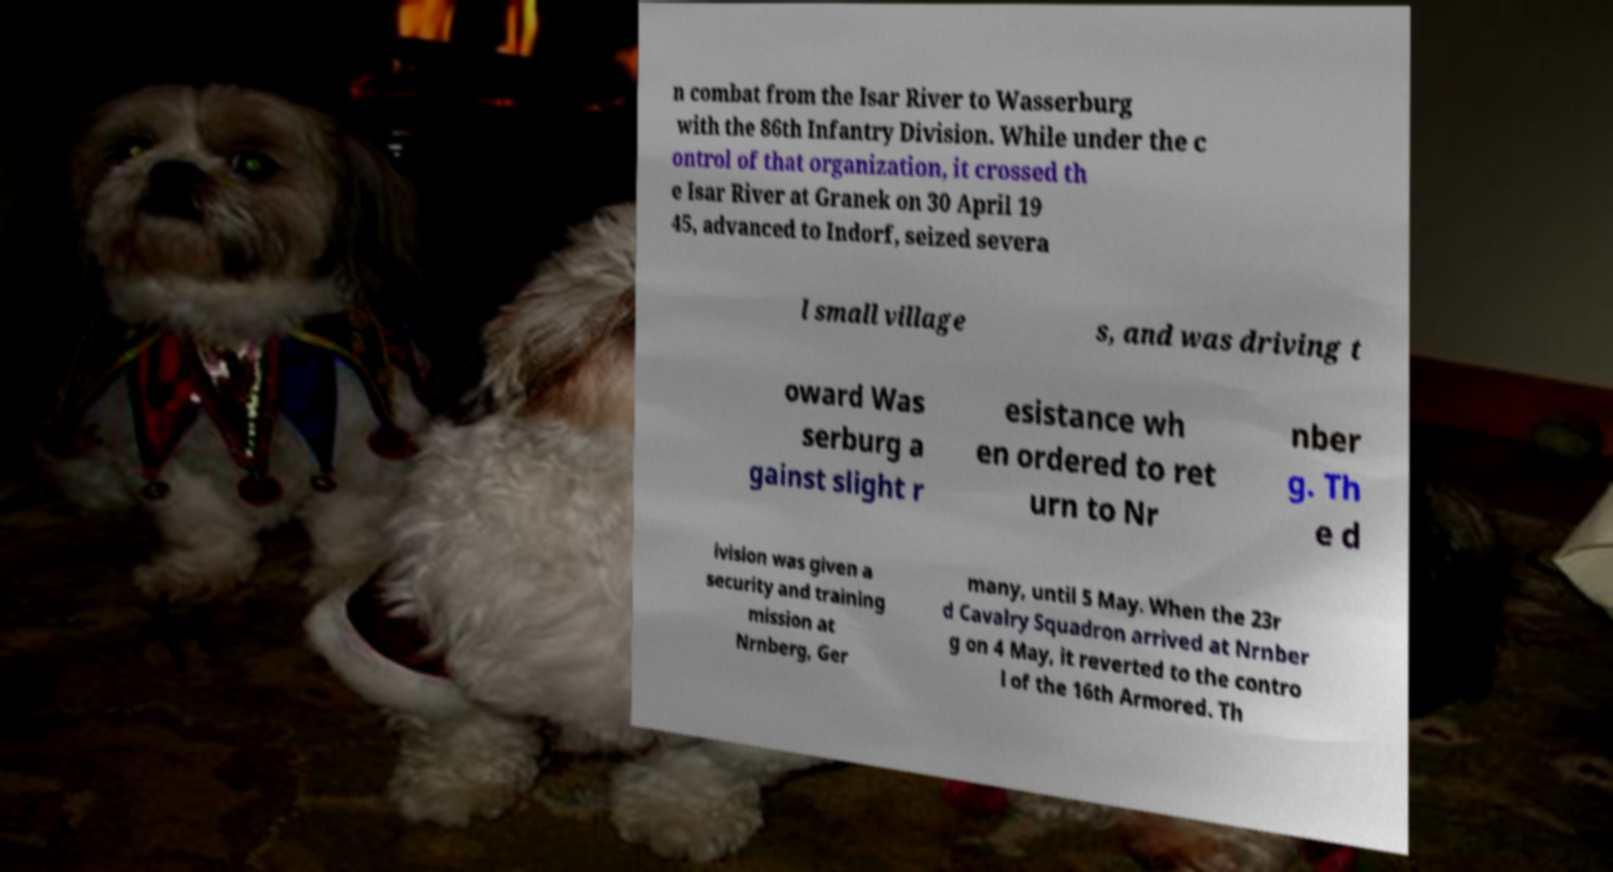Could you assist in decoding the text presented in this image and type it out clearly? n combat from the Isar River to Wasserburg with the 86th Infantry Division. While under the c ontrol of that organization, it crossed th e Isar River at Granek on 30 April 19 45, advanced to Indorf, seized severa l small village s, and was driving t oward Was serburg a gainst slight r esistance wh en ordered to ret urn to Nr nber g. Th e d ivision was given a security and training mission at Nrnberg, Ger many, until 5 May. When the 23r d Cavalry Squadron arrived at Nrnber g on 4 May, it reverted to the contro l of the 16th Armored. Th 